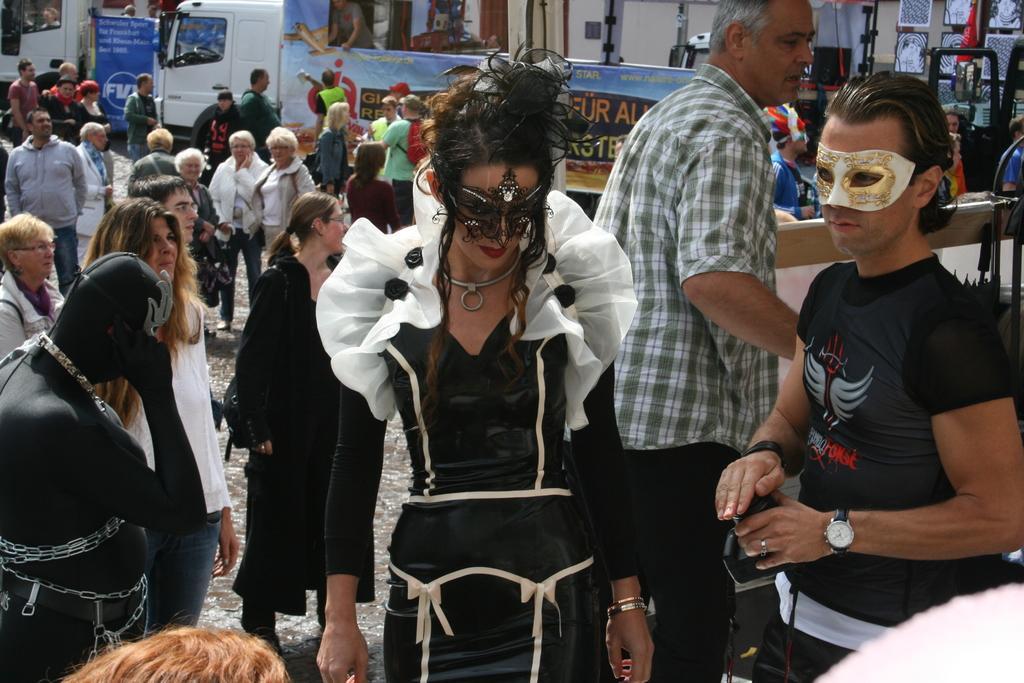How would you summarize this image in a sentence or two? In this image I can see number of people are standing and in the front I can see few of them are wearing costumes. I can also see most of people are wearing jackets. In the background I can see few vehicles, few boards and on these boards I can see something is written. 